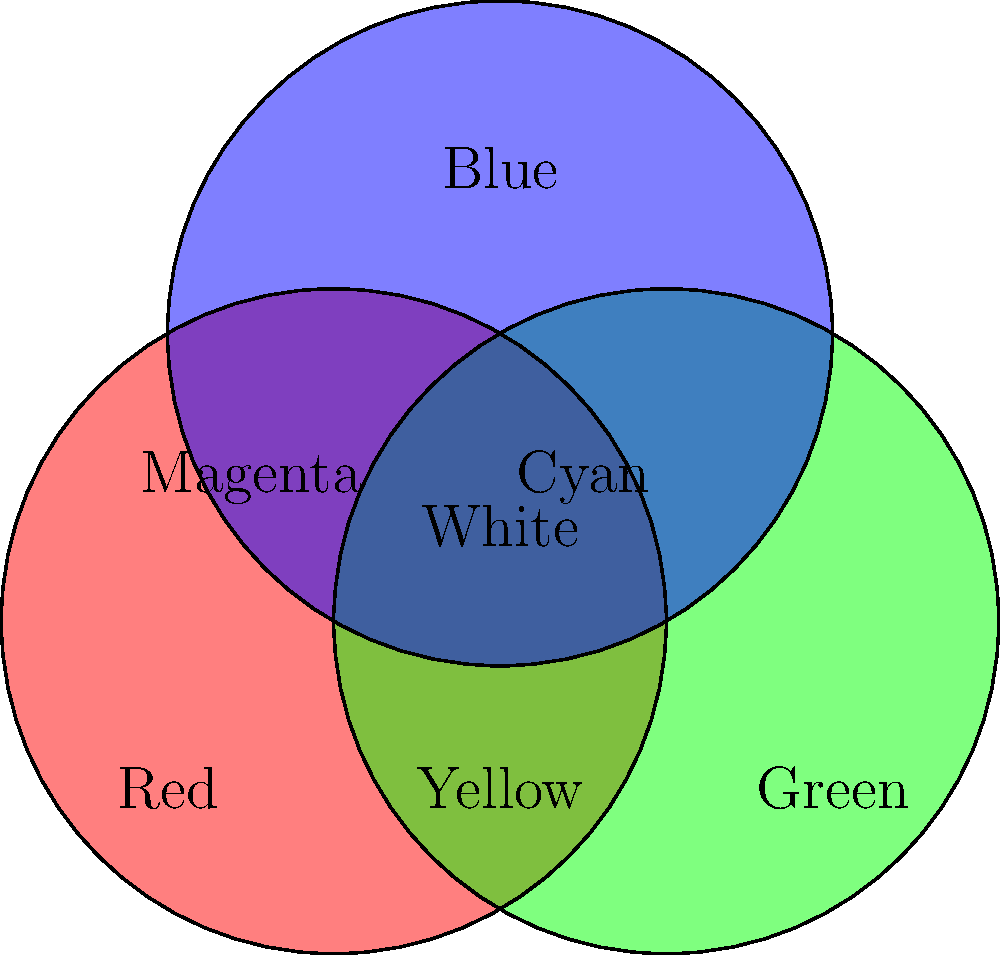In digital color mixing for film post-production, why is the combination of red, green, and blue primary colors used to create a full spectrum of colors on displays? How does this relate to the physics of light and human color perception? 1. Additive Color Mixing: Digital displays use additive color mixing, where light of different colors is combined to create new colors.

2. Primary Colors: Red, Green, and Blue (RGB) are used as primary colors because:
   a) They correspond to the peak sensitivities of the three types of cone cells in the human retina.
   b) These wavelengths are spread across the visible spectrum, allowing for a wide range of color reproduction.

3. Physics of Light:
   a) Light is composed of electromagnetic waves of different wavelengths.
   b) Each primary color represents a specific range of wavelengths:
      Red: ~620-750 nm
      Green: ~495-570 nm
      Blue: ~450-495 nm

4. Human Color Perception:
   a) The retina contains three types of cone cells, each sensitive to different wavelengths of light (roughly corresponding to red, green, and blue).
   b) The brain interprets the relative stimulation of these cones to perceive color.

5. Color Mixing:
   a) By varying the intensity of each primary color, a wide range of colors can be produced:
      Red + Green = Yellow
      Green + Blue = Cyan
      Blue + Red = Magenta
      Red + Green + Blue = White

6. Digital Implementation:
   a) Each pixel in a digital display consists of three sub-pixels (red, green, and blue).
   b) By controlling the intensity of each sub-pixel, any color within the display's gamut can be produced.

7. Advantages for Film Post-production:
   a) Precise color control for color grading and correction.
   b) Ability to reproduce a wide color gamut for various display technologies (e.g., HDR).
   c) Consistency across different devices and platforms.

This RGB system allows filmmakers and post-production artists to have fine-grained control over color representation, crucial for achieving desired visual aesthetics and maintaining color accuracy across different display technologies.
Answer: RGB mimics human trichromatic vision, enabling wide color gamut reproduction through additive mixing of primary colors corresponding to retinal cone sensitivities. 